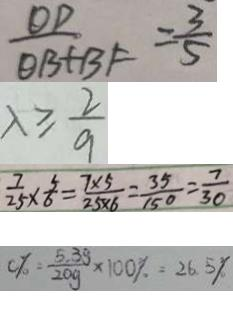<formula> <loc_0><loc_0><loc_500><loc_500>\frac { O D } { O B + B F } = \frac { 3 } { 5 } 
 \lambda \geq \frac { 2 } { 9 } 
 \frac { 7 } { 2 5 } \times \frac { 5 } { 6 } = \frac { 7 \times 5 } { 2 5 \times 6 } = \frac { 3 5 } { 1 5 0 } = \frac { 7 } { 3 0 } 
 0 \% = \frac { 5 . 3 g } { 2 0 g } \times 1 0 0 \% = 2 6 . 5 \%</formula> 